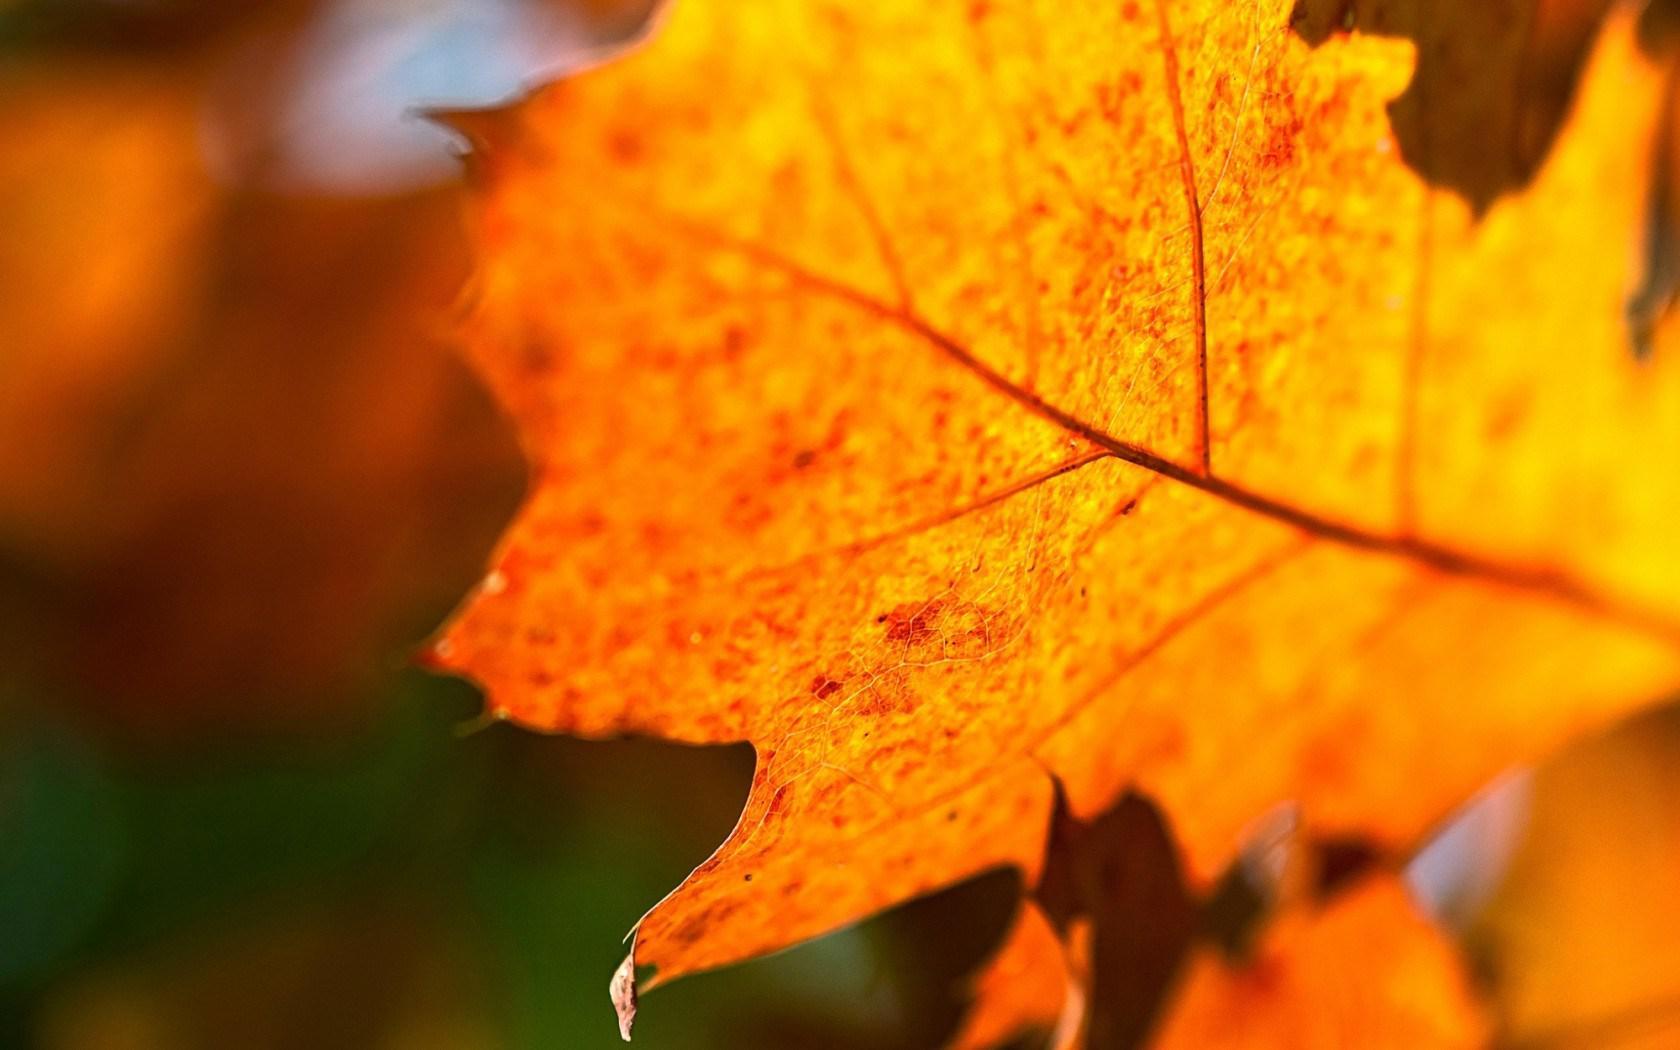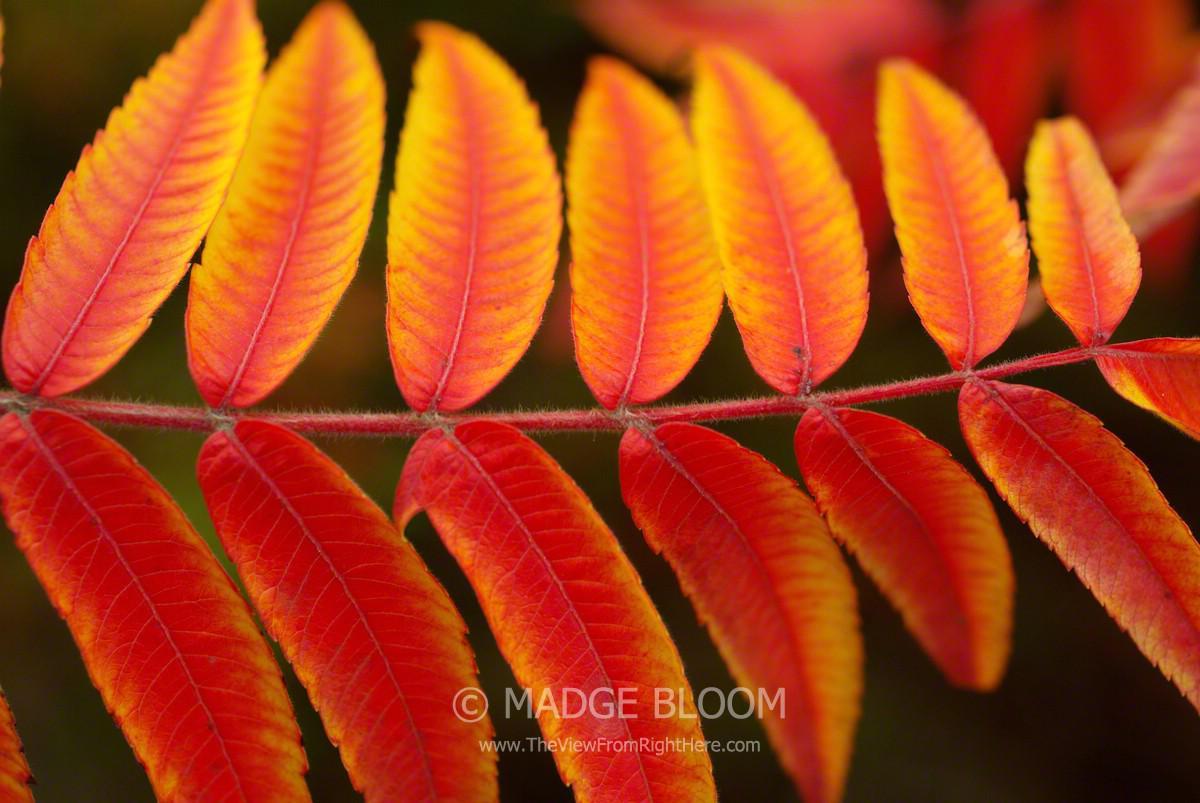The first image is the image on the left, the second image is the image on the right. Analyze the images presented: Is the assertion "The right image shows a bunch of autumn leaves shaped like maple leaves." valid? Answer yes or no. No. 